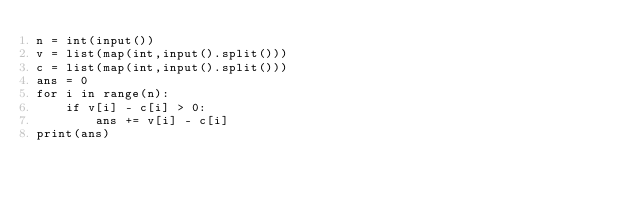Convert code to text. <code><loc_0><loc_0><loc_500><loc_500><_Python_>n = int(input())
v = list(map(int,input().split()))
c = list(map(int,input().split()))
ans = 0
for i in range(n):
    if v[i] - c[i] > 0:
        ans += v[i] - c[i]
print(ans)</code> 